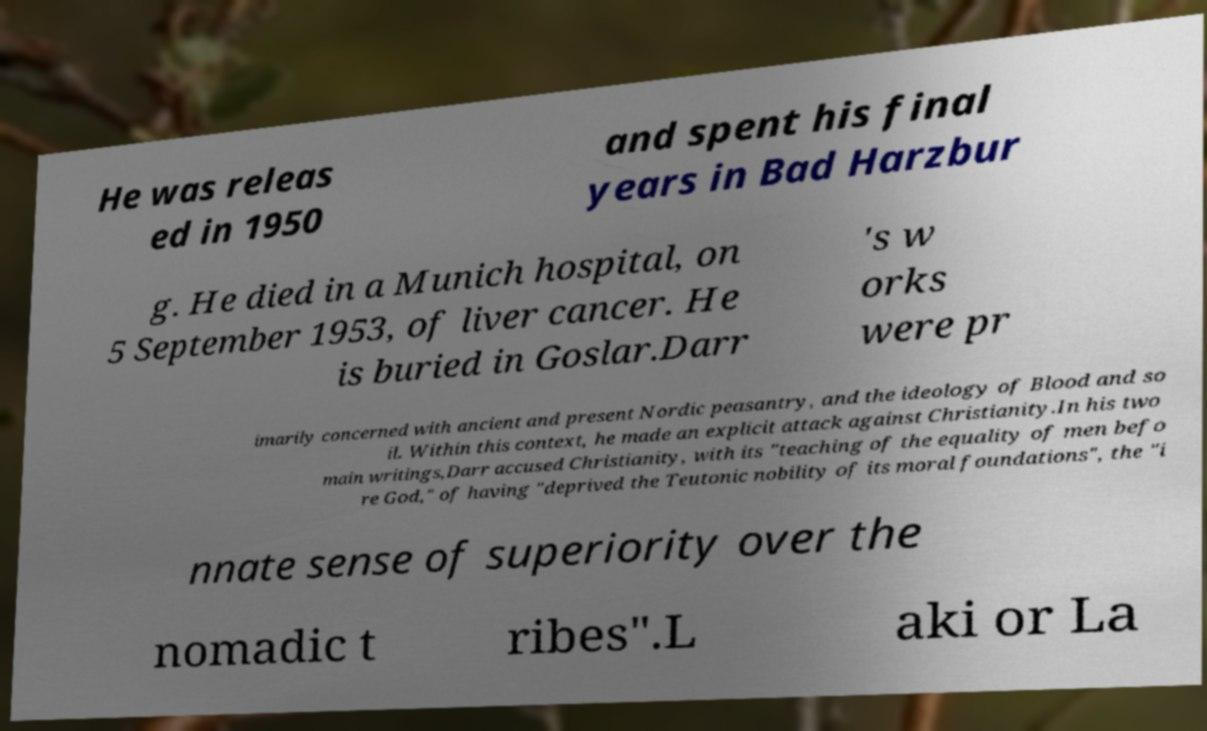I need the written content from this picture converted into text. Can you do that? He was releas ed in 1950 and spent his final years in Bad Harzbur g. He died in a Munich hospital, on 5 September 1953, of liver cancer. He is buried in Goslar.Darr 's w orks were pr imarily concerned with ancient and present Nordic peasantry, and the ideology of Blood and so il. Within this context, he made an explicit attack against Christianity.In his two main writings,Darr accused Christianity, with its "teaching of the equality of men befo re God," of having "deprived the Teutonic nobility of its moral foundations", the "i nnate sense of superiority over the nomadic t ribes".L aki or La 